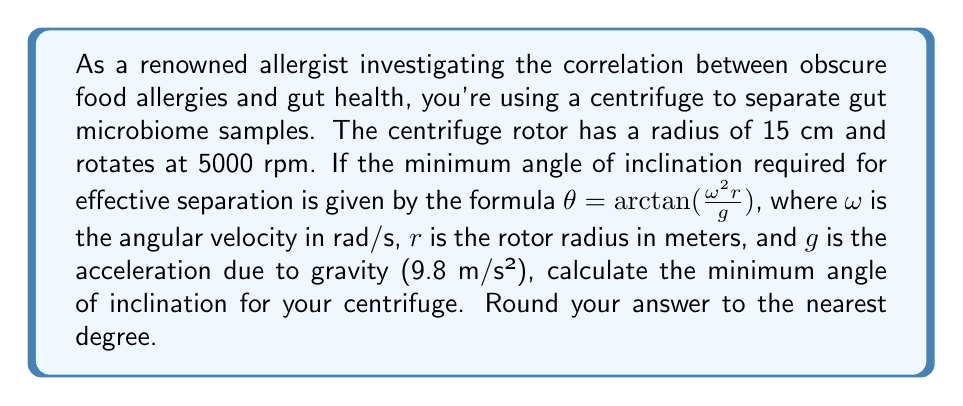Give your solution to this math problem. To solve this problem, we'll follow these steps:

1) First, we need to convert the rotational speed from rpm to rad/s:
   $\omega = 5000 \text{ rpm} \times \frac{2\pi \text{ rad}}{1 \text{ revolution}} \times \frac{1 \text{ minute}}{60 \text{ seconds}}$
   $\omega = \frac{5000 \times 2\pi}{60} = \frac{500\pi}{3} \approx 523.6 \text{ rad/s}$

2) Convert the rotor radius from cm to m:
   $r = 15 \text{ cm} = 0.15 \text{ m}$

3) Now we can substitute these values into the given formula:
   $\theta = \arctan(\frac{\omega^2 r}{g})$
   $\theta = \arctan(\frac{(523.6)^2 \times 0.15}{9.8})$

4) Calculate the value inside the parentheses:
   $\theta = \arctan(\frac{274155.8 \times 0.15}{9.8}) = \arctan(4198.4)$

5) Use a calculator to compute the arctangent:
   $\theta \approx 89.99°$

6) Rounding to the nearest degree:
   $\theta \approx 90°$

[asy]
import geometry;

size(200);
draw((-2,0)--(2,0),arrow=Arrow(TeXHead));
draw((0,-0.5)--(0,2),arrow=Arrow(TeXHead));
draw((0,0)--(1.5,1.5),arrow=Arrow(TeXHead));
draw(arc((0,0),0.5,0,90),arrow=Arrow(TeXHead));
label("$90°$",(0.2,0.5),NE);
label("$r$",(0.75,0.75),NE);
label("$g$",(0,-0.25),W);
label("$\omega^2 r$",(1.5,1.5),NE);
[/asy]

The diagram illustrates the forces acting on the sample in the centrifuge, showing why such a high angle of inclination is necessary for effective separation at high speeds.
Answer: $90°$ 